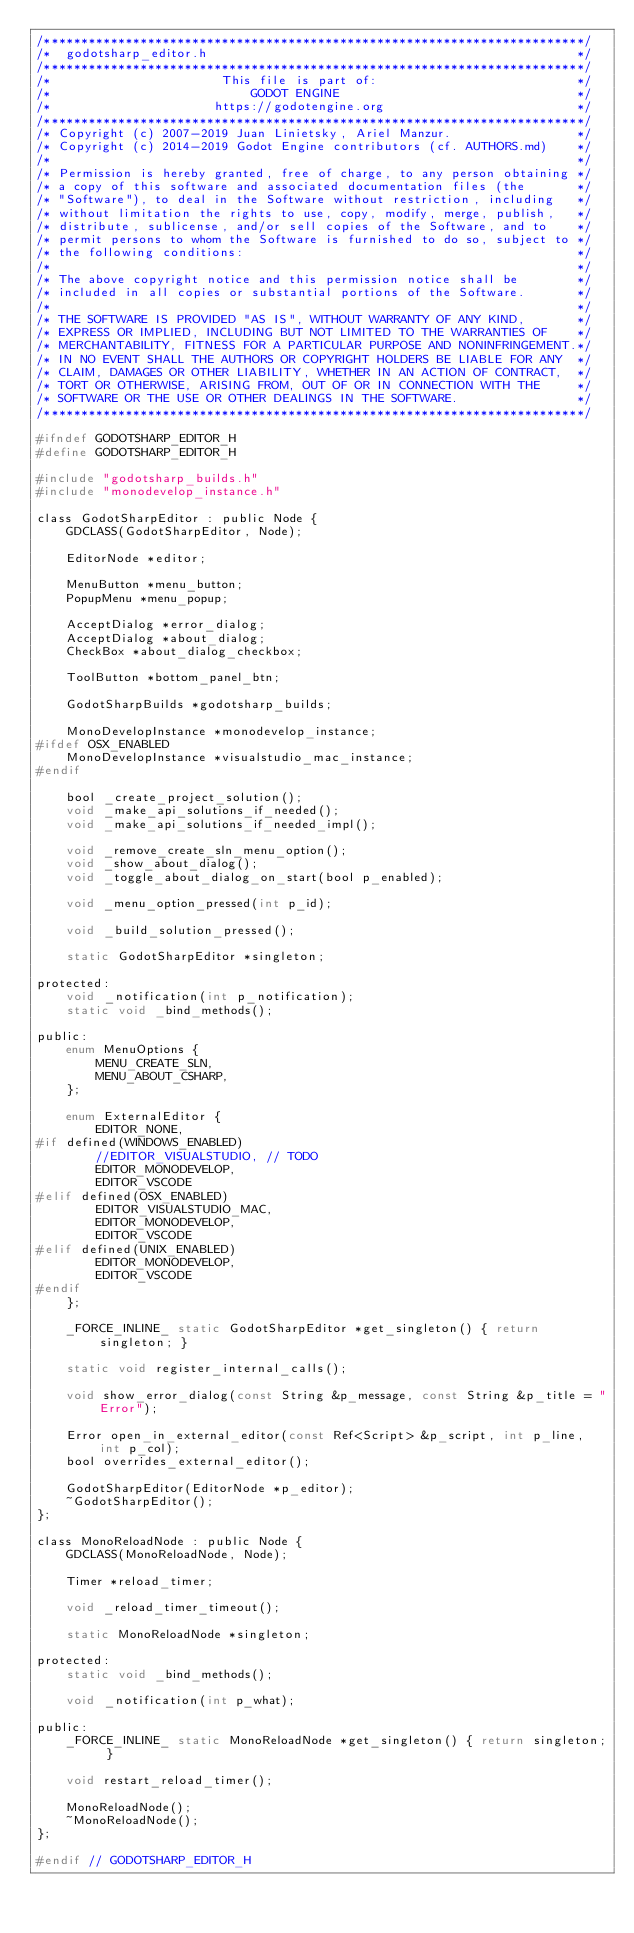Convert code to text. <code><loc_0><loc_0><loc_500><loc_500><_C_>/*************************************************************************/
/*  godotsharp_editor.h                                                  */
/*************************************************************************/
/*                       This file is part of:                           */
/*                           GODOT ENGINE                                */
/*                      https://godotengine.org                          */
/*************************************************************************/
/* Copyright (c) 2007-2019 Juan Linietsky, Ariel Manzur.                 */
/* Copyright (c) 2014-2019 Godot Engine contributors (cf. AUTHORS.md)    */
/*                                                                       */
/* Permission is hereby granted, free of charge, to any person obtaining */
/* a copy of this software and associated documentation files (the       */
/* "Software"), to deal in the Software without restriction, including   */
/* without limitation the rights to use, copy, modify, merge, publish,   */
/* distribute, sublicense, and/or sell copies of the Software, and to    */
/* permit persons to whom the Software is furnished to do so, subject to */
/* the following conditions:                                             */
/*                                                                       */
/* The above copyright notice and this permission notice shall be        */
/* included in all copies or substantial portions of the Software.       */
/*                                                                       */
/* THE SOFTWARE IS PROVIDED "AS IS", WITHOUT WARRANTY OF ANY KIND,       */
/* EXPRESS OR IMPLIED, INCLUDING BUT NOT LIMITED TO THE WARRANTIES OF    */
/* MERCHANTABILITY, FITNESS FOR A PARTICULAR PURPOSE AND NONINFRINGEMENT.*/
/* IN NO EVENT SHALL THE AUTHORS OR COPYRIGHT HOLDERS BE LIABLE FOR ANY  */
/* CLAIM, DAMAGES OR OTHER LIABILITY, WHETHER IN AN ACTION OF CONTRACT,  */
/* TORT OR OTHERWISE, ARISING FROM, OUT OF OR IN CONNECTION WITH THE     */
/* SOFTWARE OR THE USE OR OTHER DEALINGS IN THE SOFTWARE.                */
/*************************************************************************/

#ifndef GODOTSHARP_EDITOR_H
#define GODOTSHARP_EDITOR_H

#include "godotsharp_builds.h"
#include "monodevelop_instance.h"

class GodotSharpEditor : public Node {
	GDCLASS(GodotSharpEditor, Node);

	EditorNode *editor;

	MenuButton *menu_button;
	PopupMenu *menu_popup;

	AcceptDialog *error_dialog;
	AcceptDialog *about_dialog;
	CheckBox *about_dialog_checkbox;

	ToolButton *bottom_panel_btn;

	GodotSharpBuilds *godotsharp_builds;

	MonoDevelopInstance *monodevelop_instance;
#ifdef OSX_ENABLED
	MonoDevelopInstance *visualstudio_mac_instance;
#endif

	bool _create_project_solution();
	void _make_api_solutions_if_needed();
	void _make_api_solutions_if_needed_impl();

	void _remove_create_sln_menu_option();
	void _show_about_dialog();
	void _toggle_about_dialog_on_start(bool p_enabled);

	void _menu_option_pressed(int p_id);

	void _build_solution_pressed();

	static GodotSharpEditor *singleton;

protected:
	void _notification(int p_notification);
	static void _bind_methods();

public:
	enum MenuOptions {
		MENU_CREATE_SLN,
		MENU_ABOUT_CSHARP,
	};

	enum ExternalEditor {
		EDITOR_NONE,
#if defined(WINDOWS_ENABLED)
		//EDITOR_VISUALSTUDIO, // TODO
		EDITOR_MONODEVELOP,
		EDITOR_VSCODE
#elif defined(OSX_ENABLED)
		EDITOR_VISUALSTUDIO_MAC,
		EDITOR_MONODEVELOP,
		EDITOR_VSCODE
#elif defined(UNIX_ENABLED)
		EDITOR_MONODEVELOP,
		EDITOR_VSCODE
#endif
	};

	_FORCE_INLINE_ static GodotSharpEditor *get_singleton() { return singleton; }

	static void register_internal_calls();

	void show_error_dialog(const String &p_message, const String &p_title = "Error");

	Error open_in_external_editor(const Ref<Script> &p_script, int p_line, int p_col);
	bool overrides_external_editor();

	GodotSharpEditor(EditorNode *p_editor);
	~GodotSharpEditor();
};

class MonoReloadNode : public Node {
	GDCLASS(MonoReloadNode, Node);

	Timer *reload_timer;

	void _reload_timer_timeout();

	static MonoReloadNode *singleton;

protected:
	static void _bind_methods();

	void _notification(int p_what);

public:
	_FORCE_INLINE_ static MonoReloadNode *get_singleton() { return singleton; }

	void restart_reload_timer();

	MonoReloadNode();
	~MonoReloadNode();
};

#endif // GODOTSHARP_EDITOR_H
</code> 